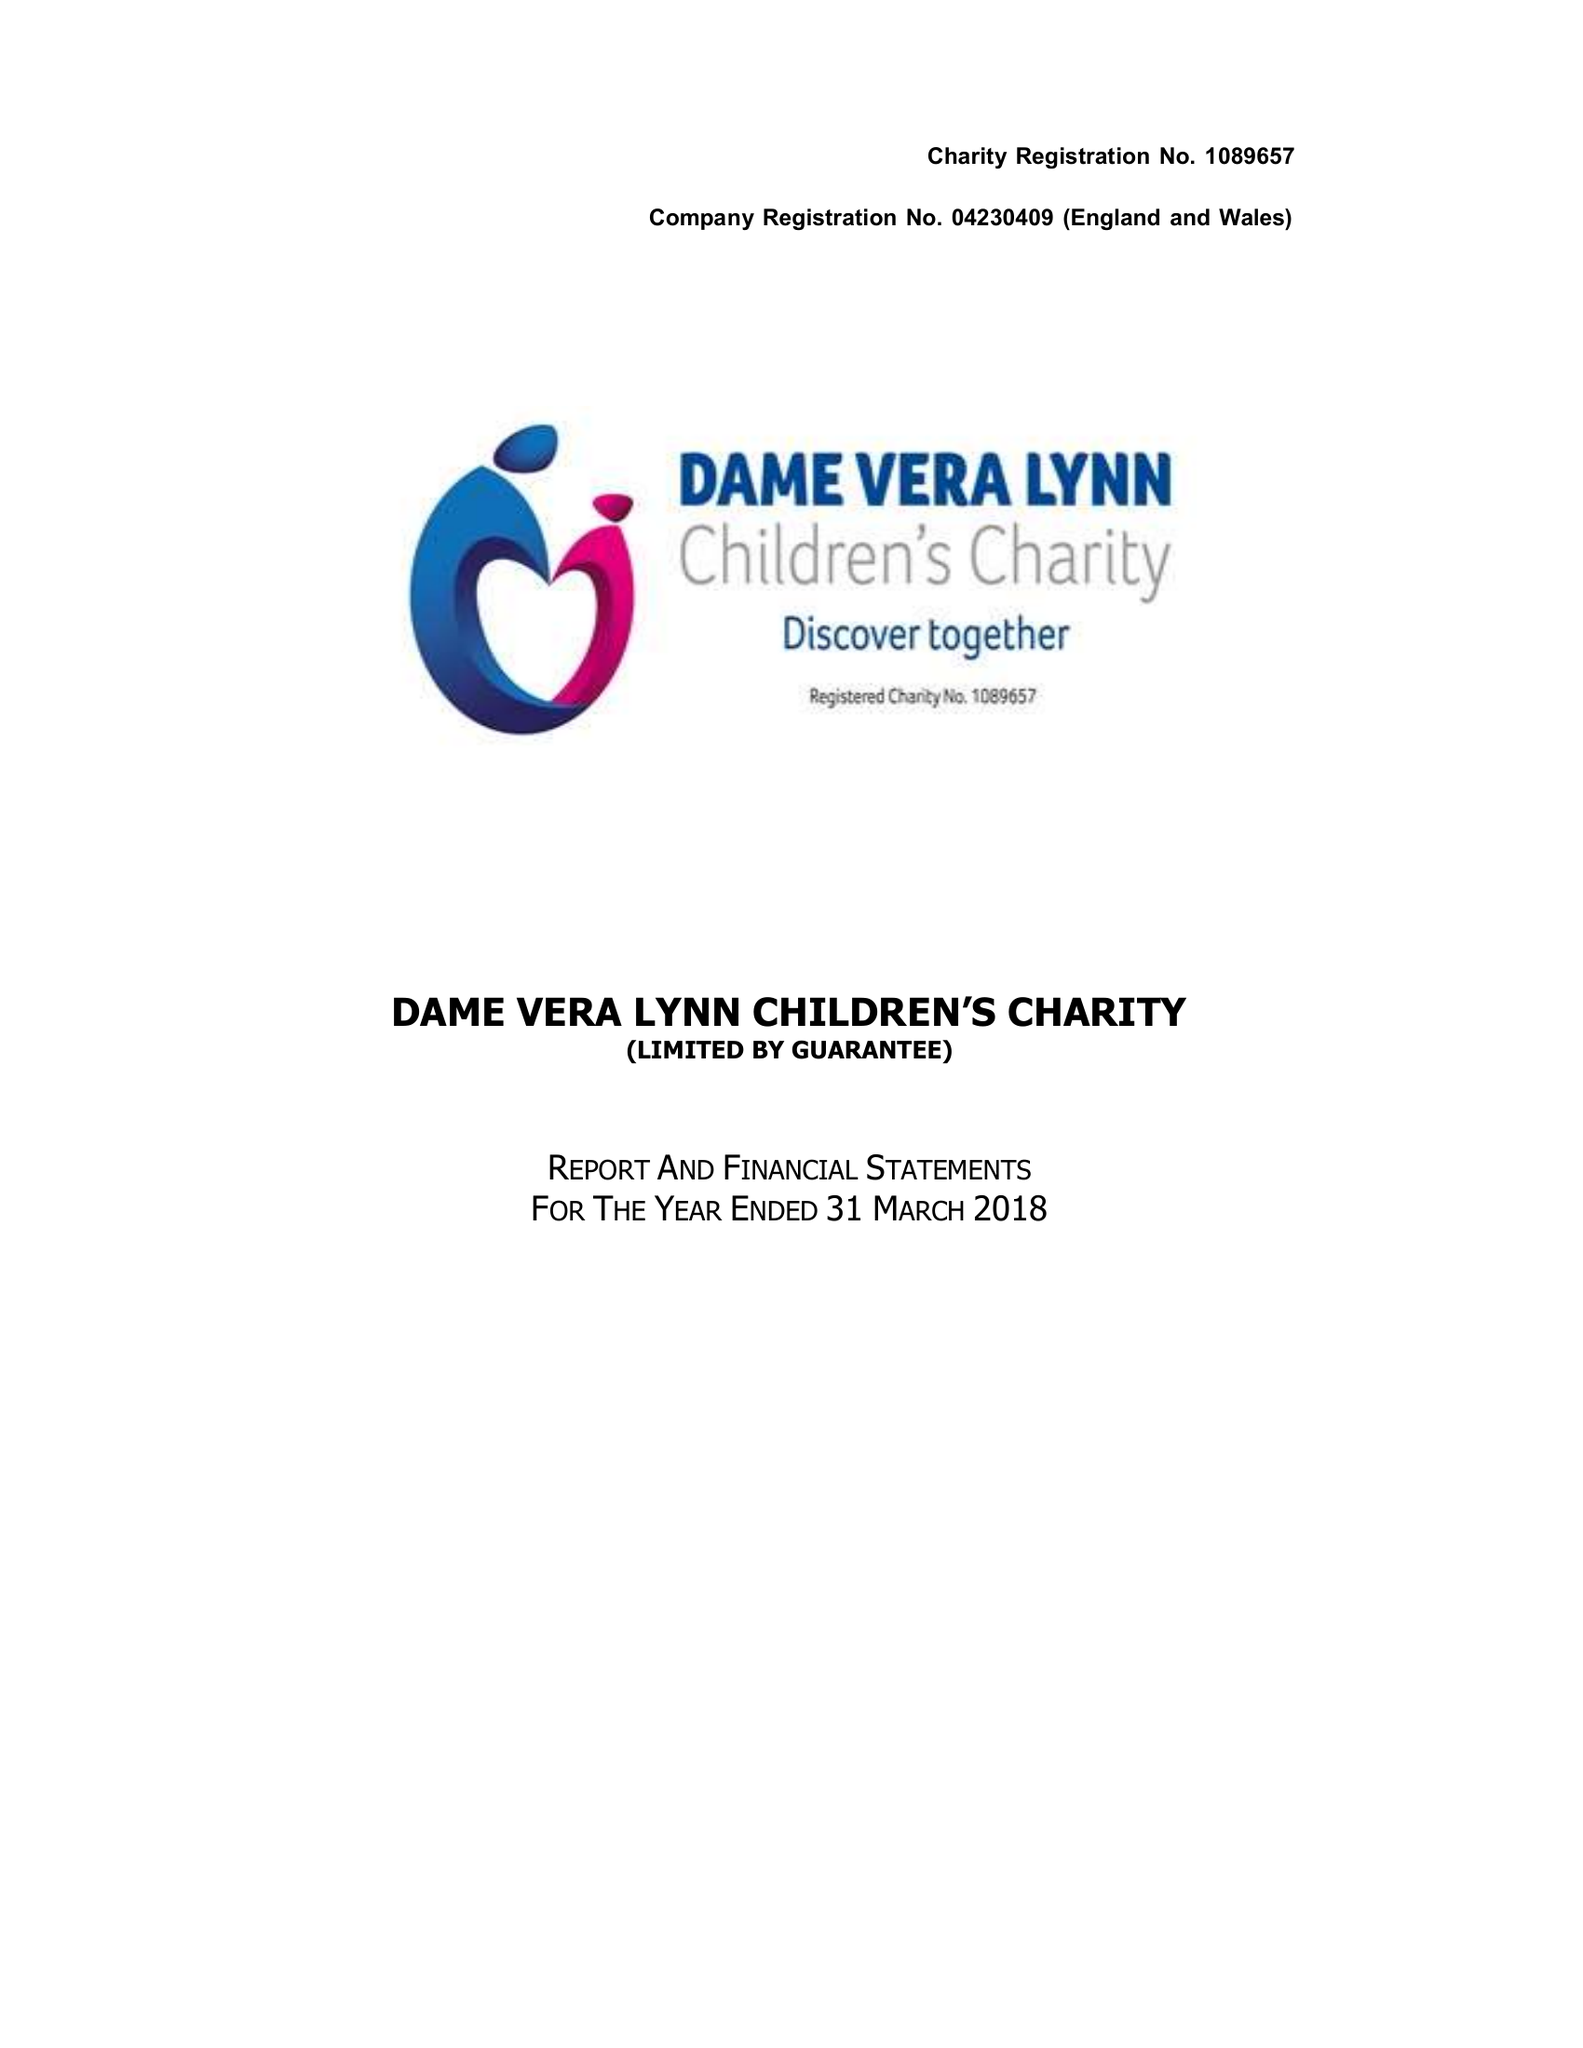What is the value for the report_date?
Answer the question using a single word or phrase. 2018-03-31 